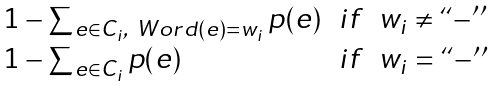Convert formula to latex. <formula><loc_0><loc_0><loc_500><loc_500>\begin{array} { l c l } 1 - \sum _ { e \in C _ { i } , \ W o r d ( e ) = w _ { i } } p ( e ) & i f & w _ { i } \neq ` ` - ^ { \prime \prime } \\ 1 - \sum _ { e \in C _ { i } } p ( e ) & i f & w _ { i } = ` ` - ^ { \prime \prime } \\ \end{array}</formula> 